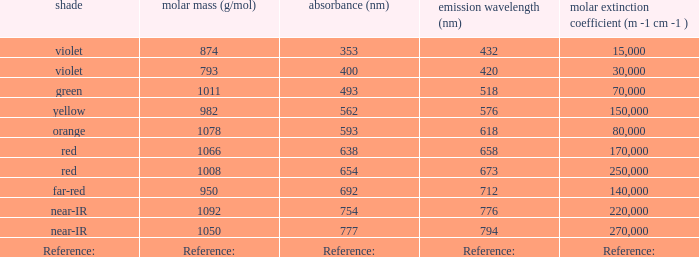What emission (in nanometers) corresponds to an absorption of 593 nm? 618.0. 